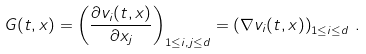<formula> <loc_0><loc_0><loc_500><loc_500>G ( t , x ) = \left ( \frac { \partial v _ { i } ( t , x ) } { \partial x _ { j } } \right ) _ { 1 \leq i , j \leq d } = \left ( \nabla v _ { i } ( t , x ) \right ) _ { 1 \leq i \leq d } \, .</formula> 